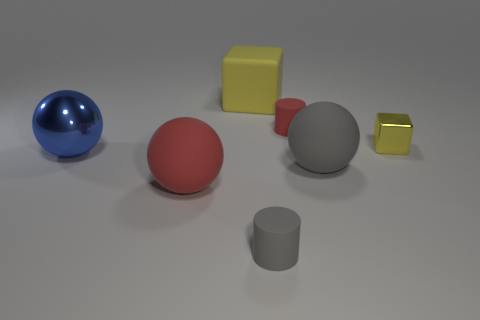Are there the same number of matte cubes on the left side of the rubber cube and green matte cubes?
Provide a succinct answer. Yes. What is the shape of the red rubber thing that is the same size as the metal cube?
Keep it short and to the point. Cylinder. What is the material of the large blue object?
Offer a very short reply. Metal. The thing that is to the left of the yellow matte object and in front of the big gray ball is what color?
Offer a terse response. Red. Is the number of large red matte objects that are behind the large rubber cube the same as the number of red cylinders in front of the red matte cylinder?
Keep it short and to the point. Yes. There is a block that is made of the same material as the tiny gray cylinder; what is its color?
Provide a short and direct response. Yellow. Is the color of the metallic block the same as the big rubber thing behind the red cylinder?
Offer a very short reply. Yes. There is a yellow cube that is on the left side of the gray thing that is to the right of the small red rubber cylinder; are there any small cubes that are behind it?
Make the answer very short. No. What is the shape of the thing that is the same material as the blue ball?
Give a very brief answer. Cube. The big yellow matte object is what shape?
Keep it short and to the point. Cube. 